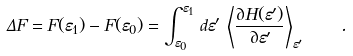Convert formula to latex. <formula><loc_0><loc_0><loc_500><loc_500>\Delta F = F ( \varepsilon _ { 1 } ) - F ( \varepsilon _ { 0 } ) = \int _ { \varepsilon _ { 0 } } ^ { \varepsilon _ { 1 } } \, d \varepsilon ^ { \prime } \, \left \langle \frac { \partial H ( \varepsilon ^ { \prime } ) } { \partial \varepsilon ^ { \prime } } \right \rangle _ { \varepsilon ^ { \prime } } \quad .</formula> 